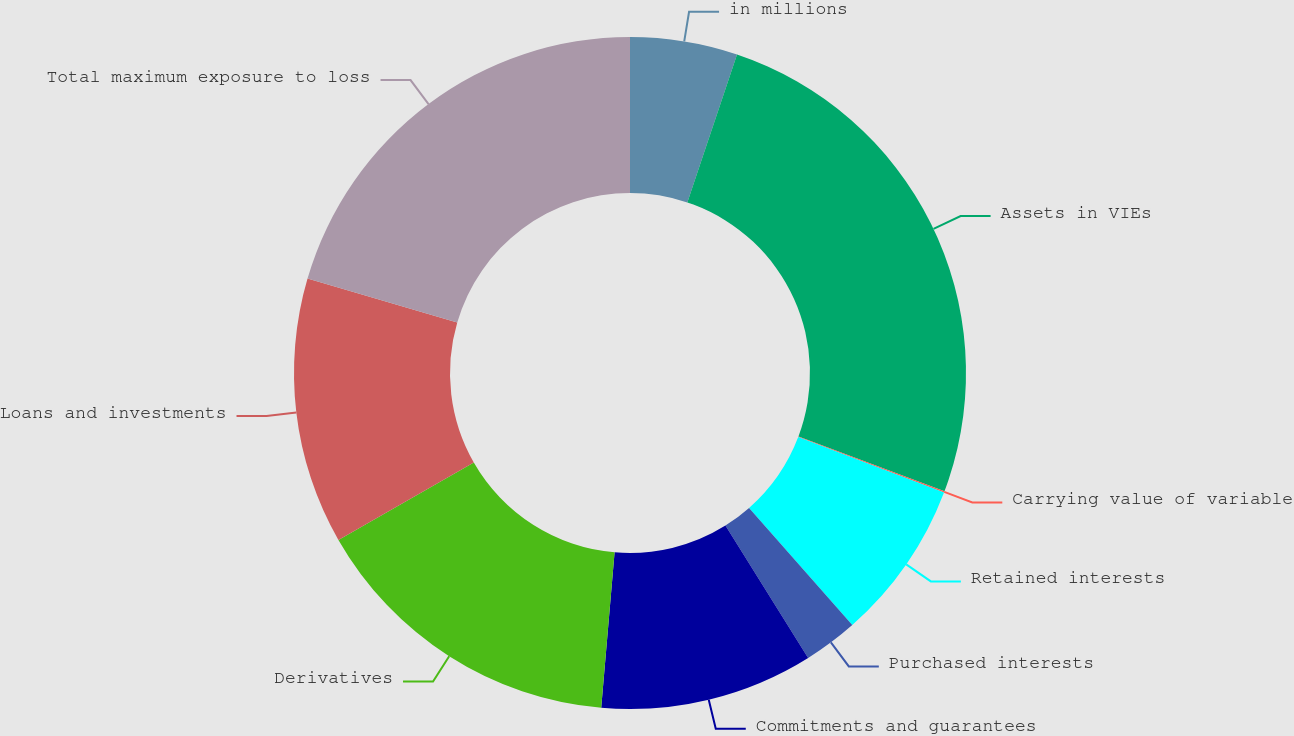<chart> <loc_0><loc_0><loc_500><loc_500><pie_chart><fcel>in millions<fcel>Assets in VIEs<fcel>Carrying value of variable<fcel>Retained interests<fcel>Purchased interests<fcel>Commitments and guarantees<fcel>Derivatives<fcel>Loans and investments<fcel>Total maximum exposure to loss<nl><fcel>5.16%<fcel>25.57%<fcel>0.06%<fcel>7.71%<fcel>2.61%<fcel>10.26%<fcel>15.36%<fcel>12.81%<fcel>20.47%<nl></chart> 